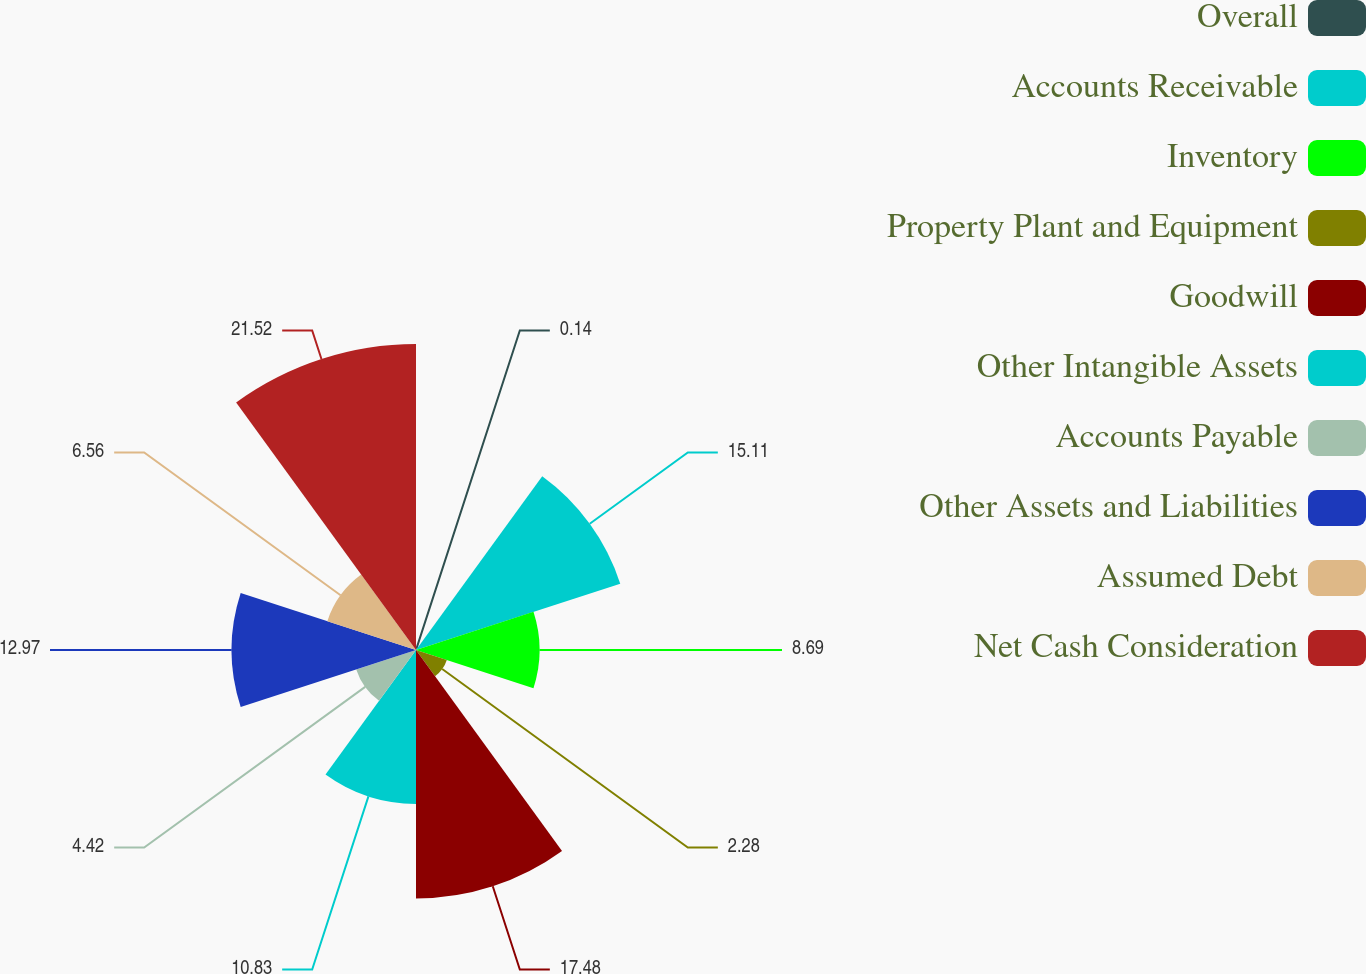<chart> <loc_0><loc_0><loc_500><loc_500><pie_chart><fcel>Overall<fcel>Accounts Receivable<fcel>Inventory<fcel>Property Plant and Equipment<fcel>Goodwill<fcel>Other Intangible Assets<fcel>Accounts Payable<fcel>Other Assets and Liabilities<fcel>Assumed Debt<fcel>Net Cash Consideration<nl><fcel>0.14%<fcel>15.11%<fcel>8.69%<fcel>2.28%<fcel>17.48%<fcel>10.83%<fcel>4.42%<fcel>12.97%<fcel>6.56%<fcel>21.53%<nl></chart> 